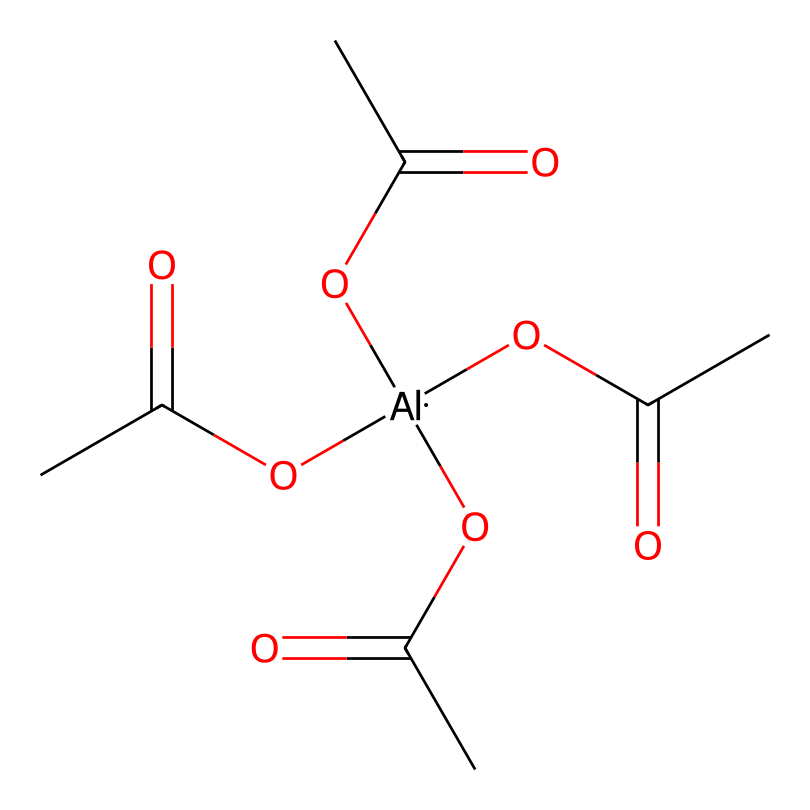What is the total number of carbon atoms in this chemical? By examining the SMILES representation, we can count the number of carbon (C) atoms present. Each "C" represents a carbon atom, and in this chemical, there are several occurrences of "C" that can be linked to different functional groups and branches. Upon counting, there are six distinct carbon atoms visible in the structure.
Answer: six How many ester functional groups are present in this molecule? An ester functional group can be identified in the chemical structure as it has the -COO- linkage. In the provided SMILES, there are multiple instances of the -COO- structure, indicating that the molecule contains three ester functional groups.
Answer: three What type of chemical is this compound generally classified as? The structure contains aluminum, acetyl groups, and ester linkages, which are typical of antacids. Given these aspects, we classify this compound generally as an aluminum-containing antacid.
Answer: aluminum-containing antacid Does this compound contain any acidic functional groups? The presence of certain functional groups can indicate acidity. In this case, the carboxylic acid (-COOH) represented in the structure implies that this compound does, in fact, have potentially acidic groups present.
Answer: yes How many different types of atoms are present in this molecule? To determine the diversity of atoms in the chemical, we refer to the SMILES notation. By analyzing it, we can identify carbon (C), hydrogen (H), oxygen (O), and aluminum (Al) as the distinct types of atoms present within the molecule. This gives us a total of four different types of atoms.
Answer: four What role does aluminum play in this antacid compound? Aluminum in antacids primarily acts as a neutralizing agent for stomach acid. In this structure, aluminum ions can interact with acids to help relieve heartburn and indigestion. This is crucial for the functionality of the antacid.
Answer: neutralizing agent 